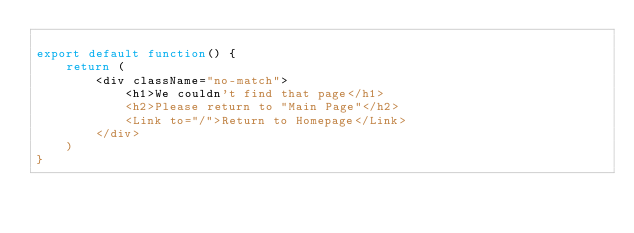<code> <loc_0><loc_0><loc_500><loc_500><_JavaScript_>
export default function() {
    return (
        <div className="no-match">
            <h1>We couldn't find that page</h1>
            <h2>Please return to "Main Page"</h2>
            <Link to="/">Return to Homepage</Link>
        </div>
    )    
}
</code> 